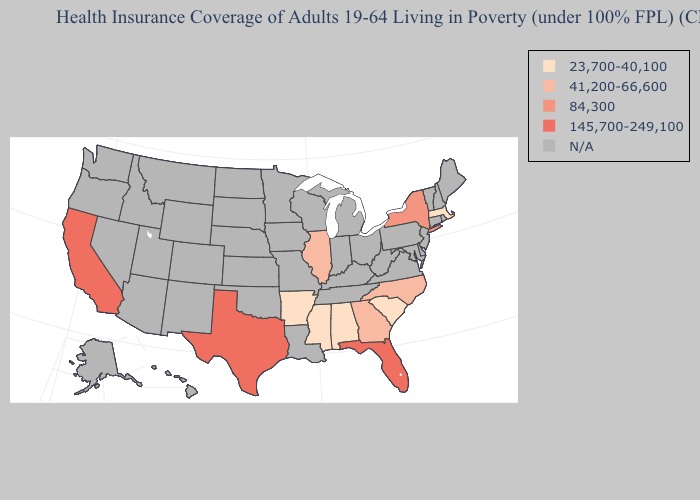What is the lowest value in states that border Mississippi?
Be succinct. 23,700-40,100. Name the states that have a value in the range 145,700-249,100?
Concise answer only. California, Florida, Texas. Name the states that have a value in the range 41,200-66,600?
Short answer required. Georgia, Illinois, North Carolina. Does Massachusetts have the highest value in the USA?
Quick response, please. No. What is the lowest value in the Northeast?
Be succinct. 23,700-40,100. Name the states that have a value in the range N/A?
Answer briefly. Alaska, Arizona, Colorado, Connecticut, Delaware, Hawaii, Idaho, Indiana, Iowa, Kansas, Kentucky, Louisiana, Maine, Maryland, Michigan, Minnesota, Missouri, Montana, Nebraska, Nevada, New Hampshire, New Jersey, New Mexico, North Dakota, Ohio, Oklahoma, Oregon, Pennsylvania, Rhode Island, South Dakota, Tennessee, Utah, Vermont, Virginia, Washington, West Virginia, Wisconsin, Wyoming. What is the value of Ohio?
Answer briefly. N/A. Does Massachusetts have the highest value in the Northeast?
Keep it brief. No. Name the states that have a value in the range 23,700-40,100?
Short answer required. Alabama, Arkansas, Massachusetts, Mississippi, South Carolina. Among the states that border Massachusetts , which have the highest value?
Write a very short answer. New York. What is the lowest value in the USA?
Quick response, please. 23,700-40,100. Which states have the lowest value in the USA?
Answer briefly. Alabama, Arkansas, Massachusetts, Mississippi, South Carolina. Name the states that have a value in the range 41,200-66,600?
Short answer required. Georgia, Illinois, North Carolina. 